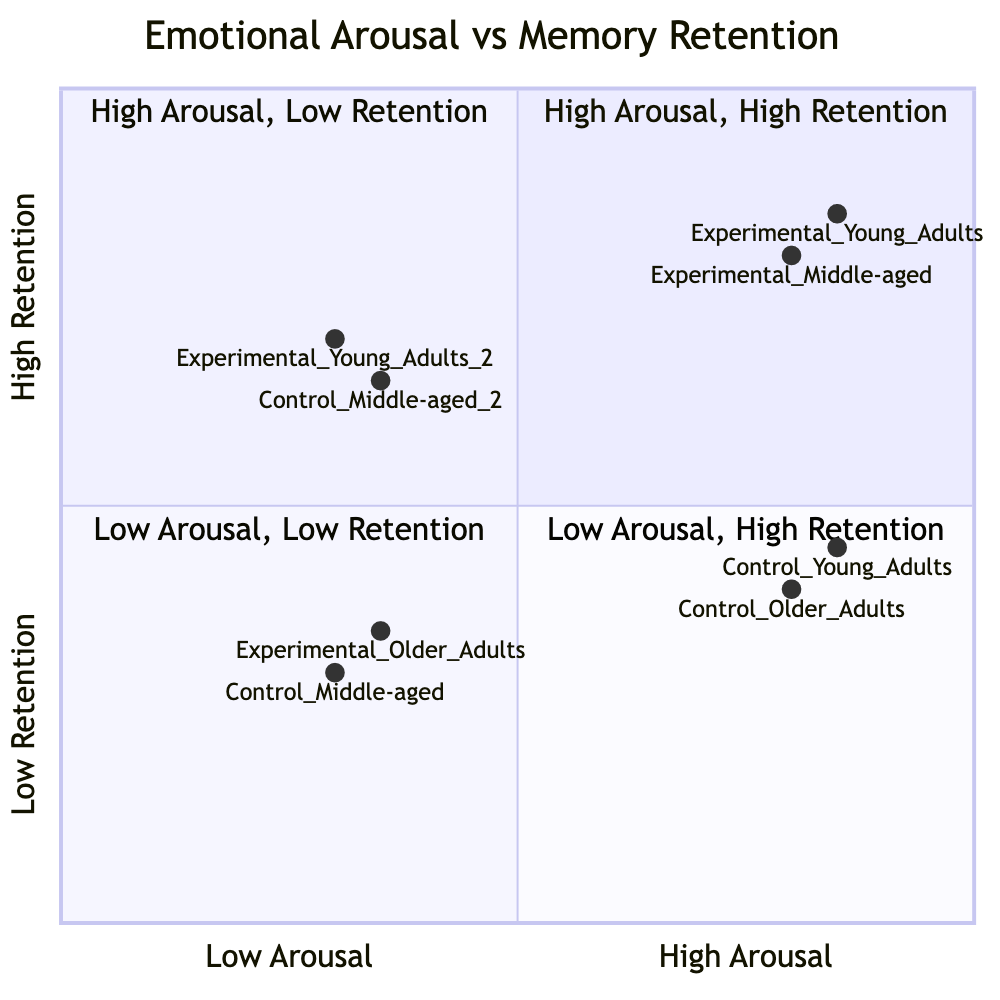What is the memory retention value for Experimental Young Adults? The diagram provides the data point for Experimental Young Adults, which is located in Quadrant 1 (High Arousal, High Retention). The value listed is 85.
Answer: 85 Which age cohort shows the highest memory retention in the experimental group? By reviewing the data points in Quadrant 1, both Young Adults (85) and Middle-aged Adults (80) belong to the Experimental group, with Young Adults having the higher value of 85.
Answer: Young Adults How many data points are in Quadrant 3? Quadrant 3 contains two data points: one for Control Middle-aged Adults (30) and one for Experimental Older Adults (35). This totals to two data points.
Answer: 2 What is the memory retention value for Control Older Adults? Control Older Adults are placed in Quadrant 2 (High Arousal, Low Retention), where the value for memory retention is specified as 40.
Answer: 40 Which group has lower memory retention, Control or Experimental, in the Low Arousal, Low Retention quadrant? In Quadrant 3, we see Control Middle-aged Adults (30) and Experimental Older Adults (35). Since 30 is lower than 35, Control has lower memory retention in this quadrant.
Answer: Control What is the Emotional Arousal level for Control Young Adults? Control Young Adults are positioned in Quadrant 2 (High Arousal, Low Retention), indicating they have high emotional arousal in this context.
Answer: High Arousal What distinguishes Quadrant 1 from Quadrant 2 in regard to memory retention? Quadrant 1 has participants exhibiting high memory retention (85 for Young Adults and 80 for Middle-aged), while Quadrant 2 reflects low retention values (45 for Young Adults and 40 for Older Adults). Thus, Quadrant 1 has high retention, whereas Quadrant 2 displays low retention.
Answer: High vs. Low Retention Which age cohort has the lowest memory retention value overall? By inspecting the values across all quadrants, Control Middle-aged Adults have the lowest memory retention value, which is 30 in Quadrant 3 (Low Arousal, Low Retention).
Answer: Middle-aged Adults In terms of Emotional Arousal, what is the relationship between Young Adults in both groups? Looking at Young Adults across Quadrants 1 and 2, the Experimental group shows high retention (85), while the Control group has high arousal but low retention (45), indicating a positive correlation with experimental methods.
Answer: Positive correlation 